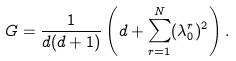<formula> <loc_0><loc_0><loc_500><loc_500>G = \frac { 1 } { d ( d + 1 ) } \left ( d + \sum _ { r = 1 } ^ { N } ( \lambda _ { 0 } ^ { r } ) ^ { 2 } \right ) .</formula> 